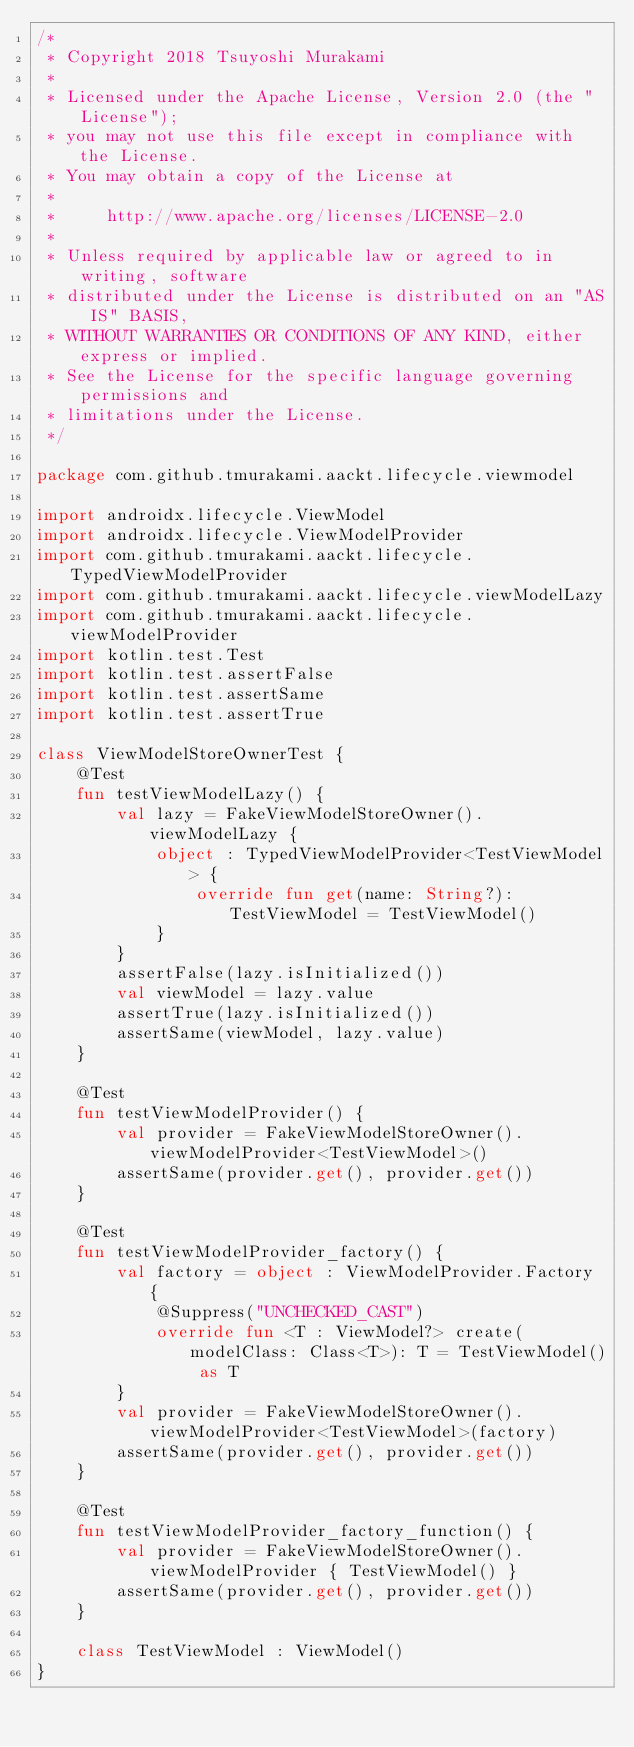Convert code to text. <code><loc_0><loc_0><loc_500><loc_500><_Kotlin_>/*
 * Copyright 2018 Tsuyoshi Murakami
 *
 * Licensed under the Apache License, Version 2.0 (the "License");
 * you may not use this file except in compliance with the License.
 * You may obtain a copy of the License at
 *
 *     http://www.apache.org/licenses/LICENSE-2.0
 *
 * Unless required by applicable law or agreed to in writing, software
 * distributed under the License is distributed on an "AS IS" BASIS,
 * WITHOUT WARRANTIES OR CONDITIONS OF ANY KIND, either express or implied.
 * See the License for the specific language governing permissions and
 * limitations under the License.
 */

package com.github.tmurakami.aackt.lifecycle.viewmodel

import androidx.lifecycle.ViewModel
import androidx.lifecycle.ViewModelProvider
import com.github.tmurakami.aackt.lifecycle.TypedViewModelProvider
import com.github.tmurakami.aackt.lifecycle.viewModelLazy
import com.github.tmurakami.aackt.lifecycle.viewModelProvider
import kotlin.test.Test
import kotlin.test.assertFalse
import kotlin.test.assertSame
import kotlin.test.assertTrue

class ViewModelStoreOwnerTest {
    @Test
    fun testViewModelLazy() {
        val lazy = FakeViewModelStoreOwner().viewModelLazy {
            object : TypedViewModelProvider<TestViewModel> {
                override fun get(name: String?): TestViewModel = TestViewModel()
            }
        }
        assertFalse(lazy.isInitialized())
        val viewModel = lazy.value
        assertTrue(lazy.isInitialized())
        assertSame(viewModel, lazy.value)
    }

    @Test
    fun testViewModelProvider() {
        val provider = FakeViewModelStoreOwner().viewModelProvider<TestViewModel>()
        assertSame(provider.get(), provider.get())
    }

    @Test
    fun testViewModelProvider_factory() {
        val factory = object : ViewModelProvider.Factory {
            @Suppress("UNCHECKED_CAST")
            override fun <T : ViewModel?> create(modelClass: Class<T>): T = TestViewModel() as T
        }
        val provider = FakeViewModelStoreOwner().viewModelProvider<TestViewModel>(factory)
        assertSame(provider.get(), provider.get())
    }

    @Test
    fun testViewModelProvider_factory_function() {
        val provider = FakeViewModelStoreOwner().viewModelProvider { TestViewModel() }
        assertSame(provider.get(), provider.get())
    }

    class TestViewModel : ViewModel()
}
</code> 